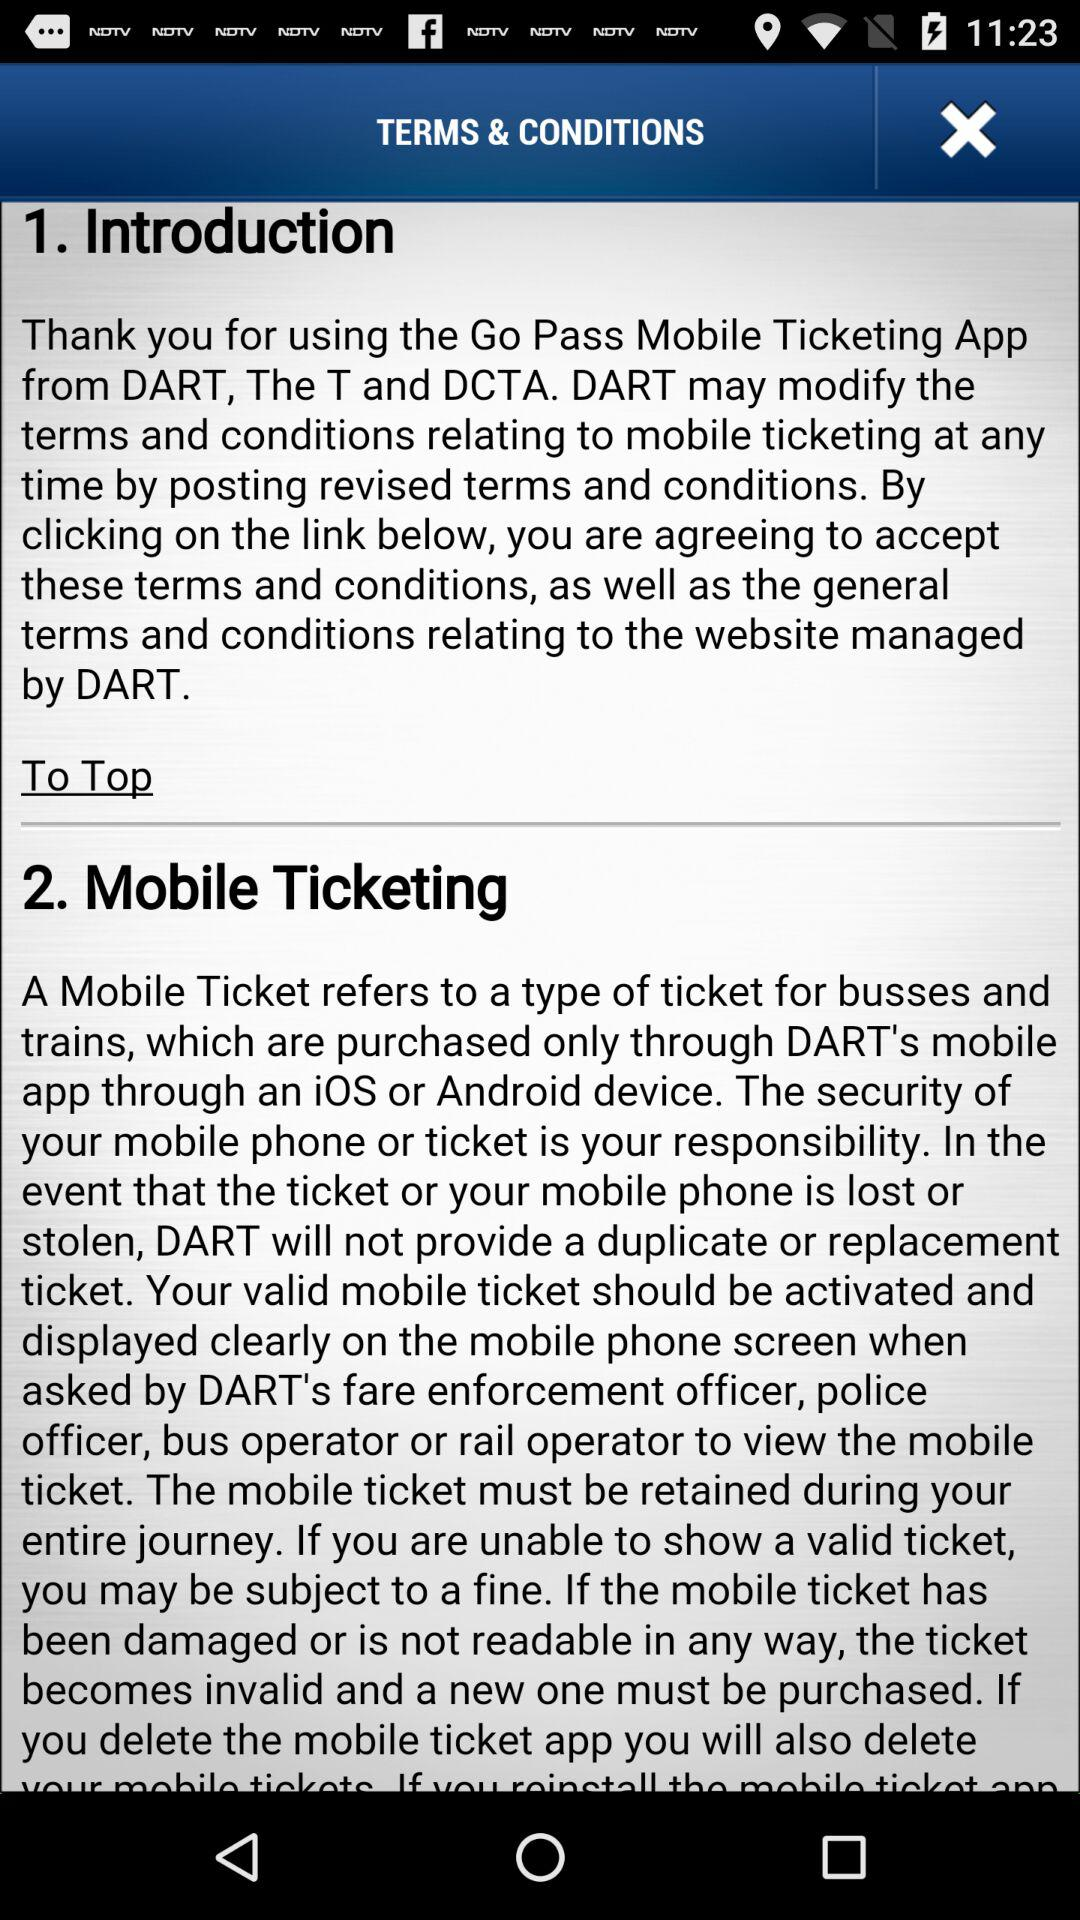What is the name of the application? The name of the application is "Go Pass". 